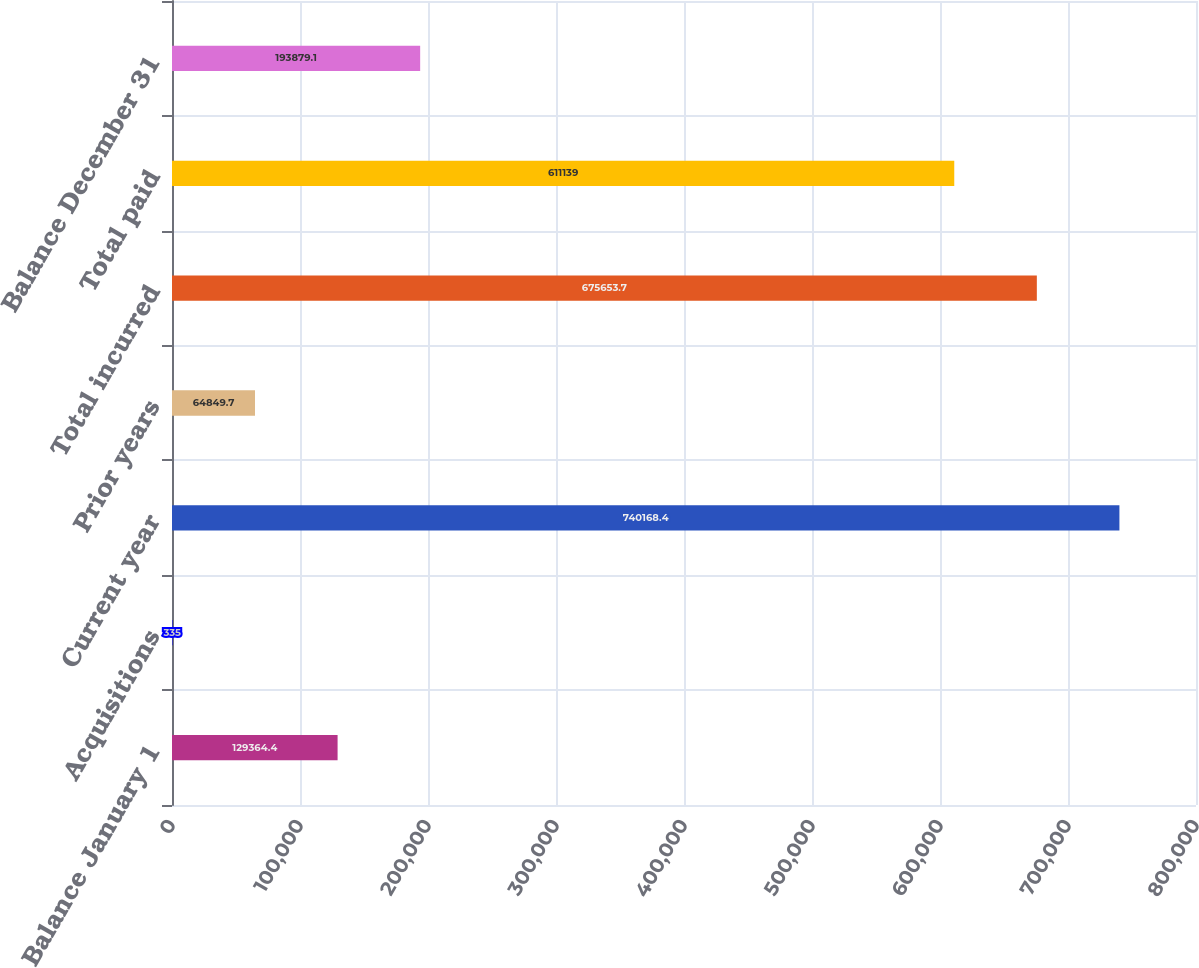Convert chart. <chart><loc_0><loc_0><loc_500><loc_500><bar_chart><fcel>Balance January 1<fcel>Acquisitions<fcel>Current year<fcel>Prior years<fcel>Total incurred<fcel>Total paid<fcel>Balance December 31<nl><fcel>129364<fcel>335<fcel>740168<fcel>64849.7<fcel>675654<fcel>611139<fcel>193879<nl></chart> 